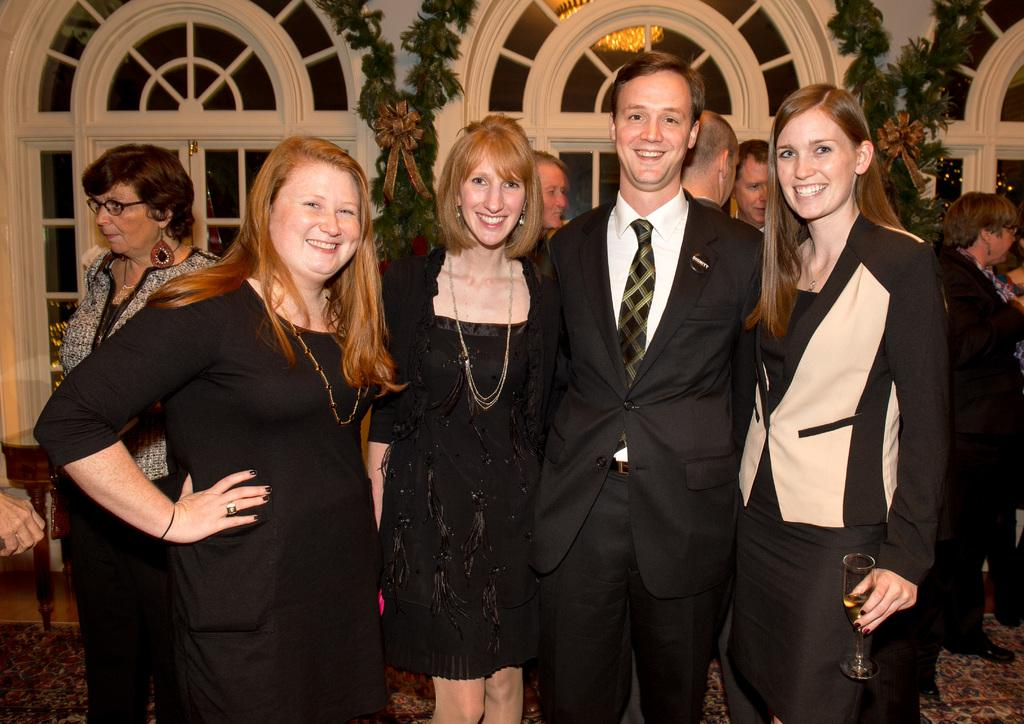What are the people in the image wearing? There are people wearing black dresses in the image. What are the people in the image doing? The people are standing and smiling. Can you describe the background of the image? There are more people in the background of the image. What type of architectural feature can be seen in the image? There are glass windows visible in the image. What type of furniture is present in the image? There is a table in the image. What statement can be made about the temperature of the hot beverage in the image? There is no hot beverage present in the image, so it is not possible to make a statement about its temperature. 